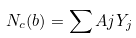<formula> <loc_0><loc_0><loc_500><loc_500>N _ { c } ( b ) = \sum A { j } Y _ { j }</formula> 